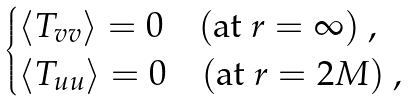Convert formula to latex. <formula><loc_0><loc_0><loc_500><loc_500>\begin{cases} \langle T _ { v v } \rangle = 0 \quad ( \text {at } r = \infty ) \ , \\ \langle T _ { u u } \rangle = 0 \quad ( \text {at } r = 2 M ) \ , \end{cases}</formula> 